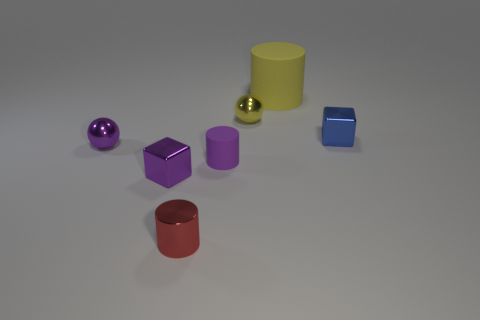Is there any other thing that is the same size as the yellow matte object?
Offer a very short reply. No. What number of red objects are either shiny cubes or tiny spheres?
Make the answer very short. 0. How many small blue shiny blocks are in front of the metal sphere in front of the blue block?
Offer a very short reply. 0. What number of other objects are there of the same shape as the yellow metallic thing?
Your answer should be compact. 1. What is the material of the cube that is the same color as the tiny matte cylinder?
Make the answer very short. Metal. How many small metallic balls have the same color as the large object?
Your response must be concise. 1. There is a cylinder that is the same material as the big yellow object; what is its color?
Offer a very short reply. Purple. Is there a yellow sphere that has the same size as the blue metal cube?
Your answer should be very brief. Yes. Are there more tiny shiny objects right of the big cylinder than rubber cylinders left of the tiny purple rubber cylinder?
Provide a succinct answer. Yes. Do the large cylinder behind the tiny blue thing and the cube behind the tiny purple cube have the same material?
Keep it short and to the point. No. 